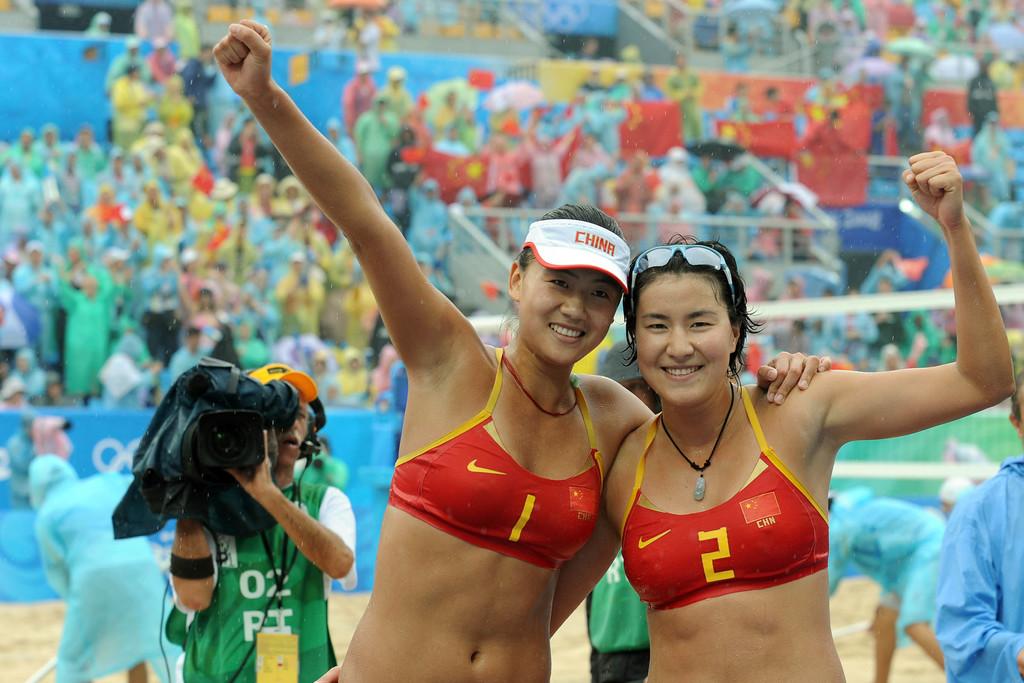Where are these athletes from?
Your response must be concise. China. What is the player number on the left?
Your answer should be very brief. 1. 